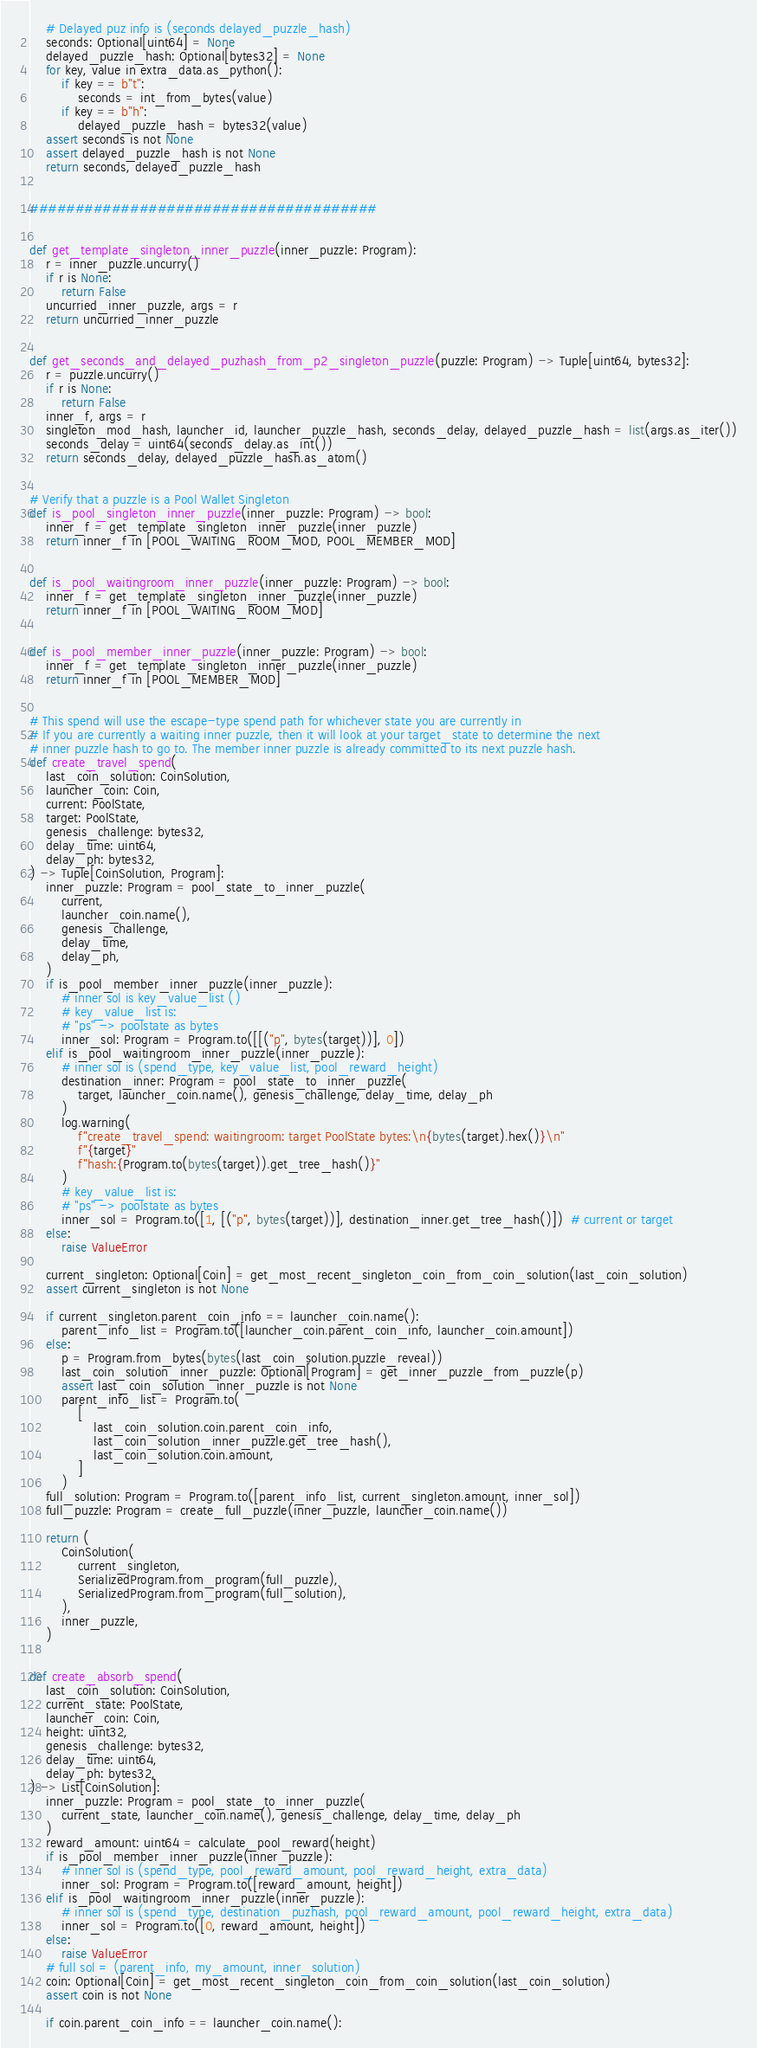<code> <loc_0><loc_0><loc_500><loc_500><_Python_>    # Delayed puz info is (seconds delayed_puzzle_hash)
    seconds: Optional[uint64] = None
    delayed_puzzle_hash: Optional[bytes32] = None
    for key, value in extra_data.as_python():
        if key == b"t":
            seconds = int_from_bytes(value)
        if key == b"h":
            delayed_puzzle_hash = bytes32(value)
    assert seconds is not None
    assert delayed_puzzle_hash is not None
    return seconds, delayed_puzzle_hash


######################################


def get_template_singleton_inner_puzzle(inner_puzzle: Program):
    r = inner_puzzle.uncurry()
    if r is None:
        return False
    uncurried_inner_puzzle, args = r
    return uncurried_inner_puzzle


def get_seconds_and_delayed_puzhash_from_p2_singleton_puzzle(puzzle: Program) -> Tuple[uint64, bytes32]:
    r = puzzle.uncurry()
    if r is None:
        return False
    inner_f, args = r
    singleton_mod_hash, launcher_id, launcher_puzzle_hash, seconds_delay, delayed_puzzle_hash = list(args.as_iter())
    seconds_delay = uint64(seconds_delay.as_int())
    return seconds_delay, delayed_puzzle_hash.as_atom()


# Verify that a puzzle is a Pool Wallet Singleton
def is_pool_singleton_inner_puzzle(inner_puzzle: Program) -> bool:
    inner_f = get_template_singleton_inner_puzzle(inner_puzzle)
    return inner_f in [POOL_WAITING_ROOM_MOD, POOL_MEMBER_MOD]


def is_pool_waitingroom_inner_puzzle(inner_puzzle: Program) -> bool:
    inner_f = get_template_singleton_inner_puzzle(inner_puzzle)
    return inner_f in [POOL_WAITING_ROOM_MOD]


def is_pool_member_inner_puzzle(inner_puzzle: Program) -> bool:
    inner_f = get_template_singleton_inner_puzzle(inner_puzzle)
    return inner_f in [POOL_MEMBER_MOD]


# This spend will use the escape-type spend path for whichever state you are currently in
# If you are currently a waiting inner puzzle, then it will look at your target_state to determine the next
# inner puzzle hash to go to. The member inner puzzle is already committed to its next puzzle hash.
def create_travel_spend(
    last_coin_solution: CoinSolution,
    launcher_coin: Coin,
    current: PoolState,
    target: PoolState,
    genesis_challenge: bytes32,
    delay_time: uint64,
    delay_ph: bytes32,
) -> Tuple[CoinSolution, Program]:
    inner_puzzle: Program = pool_state_to_inner_puzzle(
        current,
        launcher_coin.name(),
        genesis_challenge,
        delay_time,
        delay_ph,
    )
    if is_pool_member_inner_puzzle(inner_puzzle):
        # inner sol is key_value_list ()
        # key_value_list is:
        # "ps" -> poolstate as bytes
        inner_sol: Program = Program.to([[("p", bytes(target))], 0])
    elif is_pool_waitingroom_inner_puzzle(inner_puzzle):
        # inner sol is (spend_type, key_value_list, pool_reward_height)
        destination_inner: Program = pool_state_to_inner_puzzle(
            target, launcher_coin.name(), genesis_challenge, delay_time, delay_ph
        )
        log.warning(
            f"create_travel_spend: waitingroom: target PoolState bytes:\n{bytes(target).hex()}\n"
            f"{target}"
            f"hash:{Program.to(bytes(target)).get_tree_hash()}"
        )
        # key_value_list is:
        # "ps" -> poolstate as bytes
        inner_sol = Program.to([1, [("p", bytes(target))], destination_inner.get_tree_hash()])  # current or target
    else:
        raise ValueError

    current_singleton: Optional[Coin] = get_most_recent_singleton_coin_from_coin_solution(last_coin_solution)
    assert current_singleton is not None

    if current_singleton.parent_coin_info == launcher_coin.name():
        parent_info_list = Program.to([launcher_coin.parent_coin_info, launcher_coin.amount])
    else:
        p = Program.from_bytes(bytes(last_coin_solution.puzzle_reveal))
        last_coin_solution_inner_puzzle: Optional[Program] = get_inner_puzzle_from_puzzle(p)
        assert last_coin_solution_inner_puzzle is not None
        parent_info_list = Program.to(
            [
                last_coin_solution.coin.parent_coin_info,
                last_coin_solution_inner_puzzle.get_tree_hash(),
                last_coin_solution.coin.amount,
            ]
        )
    full_solution: Program = Program.to([parent_info_list, current_singleton.amount, inner_sol])
    full_puzzle: Program = create_full_puzzle(inner_puzzle, launcher_coin.name())

    return (
        CoinSolution(
            current_singleton,
            SerializedProgram.from_program(full_puzzle),
            SerializedProgram.from_program(full_solution),
        ),
        inner_puzzle,
    )


def create_absorb_spend(
    last_coin_solution: CoinSolution,
    current_state: PoolState,
    launcher_coin: Coin,
    height: uint32,
    genesis_challenge: bytes32,
    delay_time: uint64,
    delay_ph: bytes32,
) -> List[CoinSolution]:
    inner_puzzle: Program = pool_state_to_inner_puzzle(
        current_state, launcher_coin.name(), genesis_challenge, delay_time, delay_ph
    )
    reward_amount: uint64 = calculate_pool_reward(height)
    if is_pool_member_inner_puzzle(inner_puzzle):
        # inner sol is (spend_type, pool_reward_amount, pool_reward_height, extra_data)
        inner_sol: Program = Program.to([reward_amount, height])
    elif is_pool_waitingroom_inner_puzzle(inner_puzzle):
        # inner sol is (spend_type, destination_puzhash, pool_reward_amount, pool_reward_height, extra_data)
        inner_sol = Program.to([0, reward_amount, height])
    else:
        raise ValueError
    # full sol = (parent_info, my_amount, inner_solution)
    coin: Optional[Coin] = get_most_recent_singleton_coin_from_coin_solution(last_coin_solution)
    assert coin is not None

    if coin.parent_coin_info == launcher_coin.name():</code> 